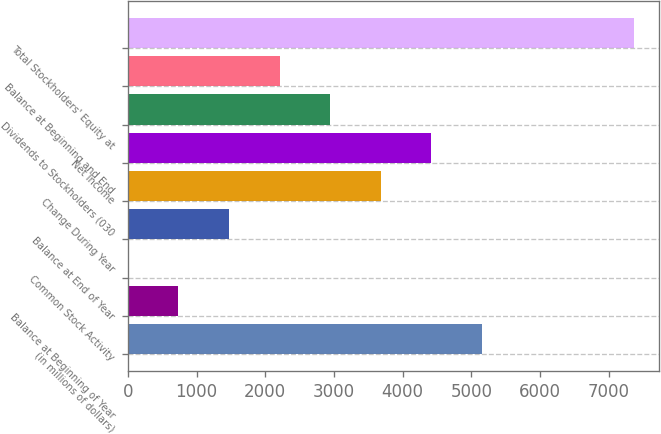Convert chart to OTSL. <chart><loc_0><loc_0><loc_500><loc_500><bar_chart><fcel>(in millions of dollars)<fcel>Balance at Beginning of Year<fcel>Common Stock Activity<fcel>Balance at End of Year<fcel>Change During Year<fcel>Net Income<fcel>Dividends to Stockholders (030<fcel>Balance at Beginning and End<fcel>Total Stockholders' Equity at<nl><fcel>5154.82<fcel>736.66<fcel>0.3<fcel>1473.02<fcel>3682.1<fcel>4418.46<fcel>2945.74<fcel>2209.38<fcel>7363.9<nl></chart> 